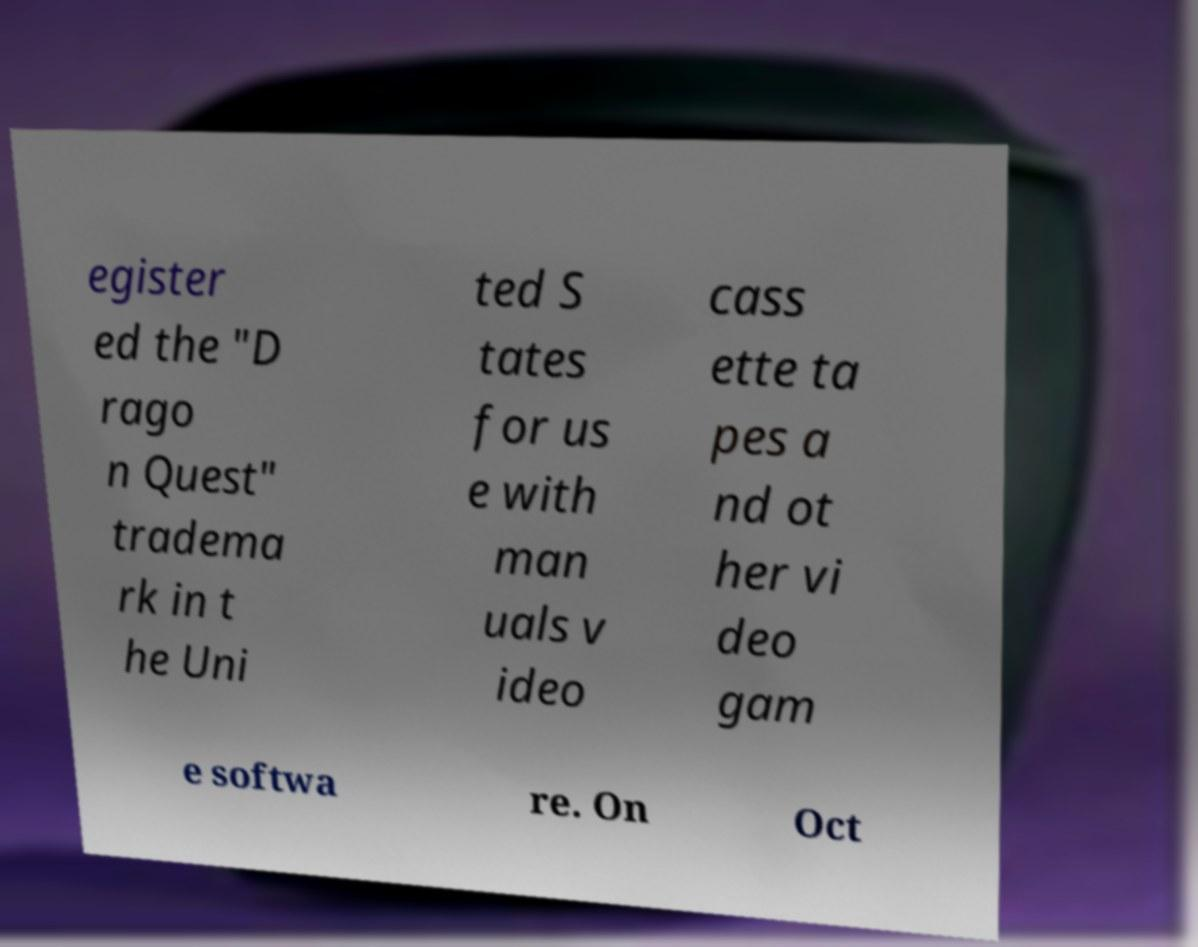Can you accurately transcribe the text from the provided image for me? egister ed the "D rago n Quest" tradema rk in t he Uni ted S tates for us e with man uals v ideo cass ette ta pes a nd ot her vi deo gam e softwa re. On Oct 